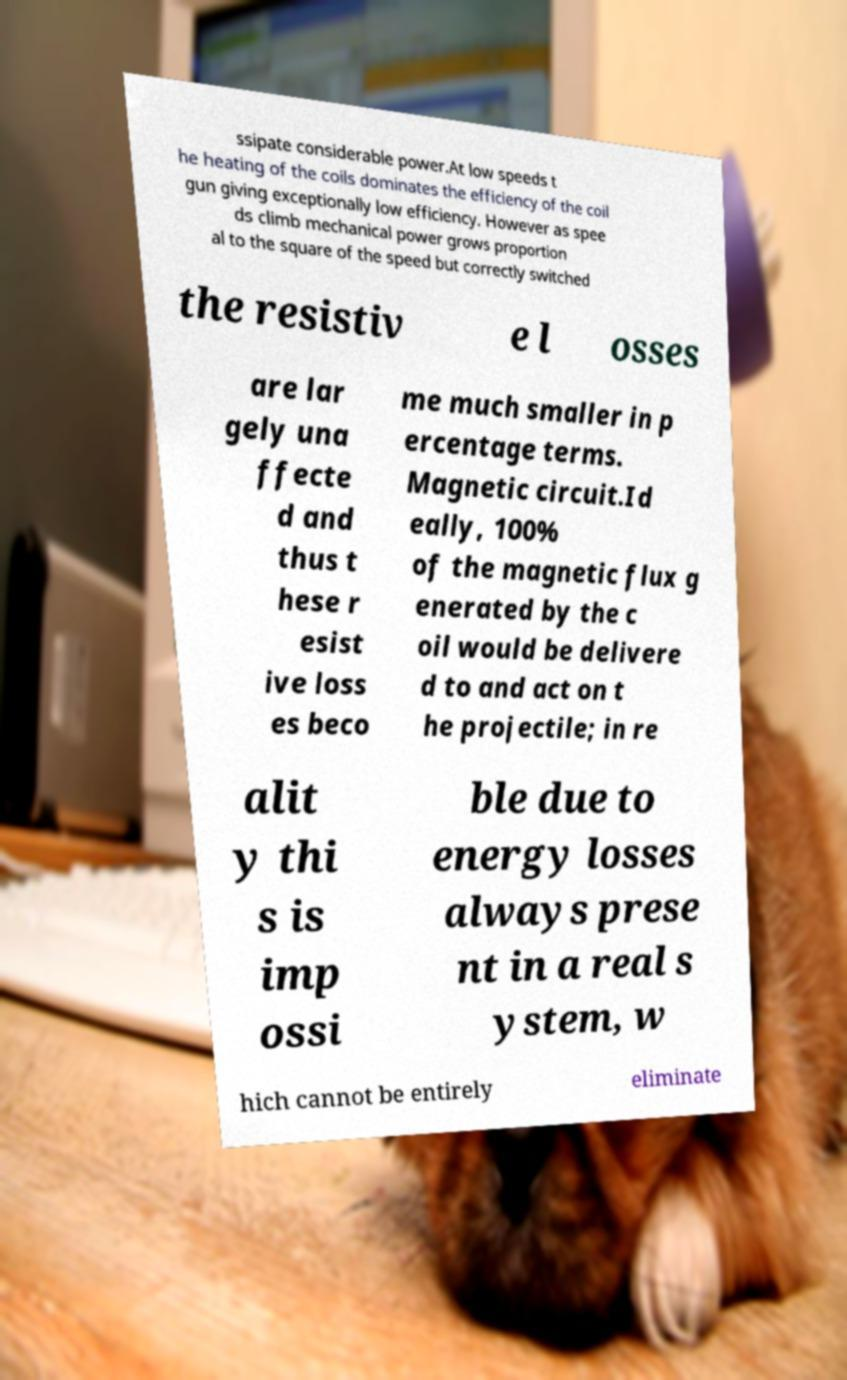Please identify and transcribe the text found in this image. ssipate considerable power.At low speeds t he heating of the coils dominates the efficiency of the coil gun giving exceptionally low efficiency. However as spee ds climb mechanical power grows proportion al to the square of the speed but correctly switched the resistiv e l osses are lar gely una ffecte d and thus t hese r esist ive loss es beco me much smaller in p ercentage terms. Magnetic circuit.Id eally, 100% of the magnetic flux g enerated by the c oil would be delivere d to and act on t he projectile; in re alit y thi s is imp ossi ble due to energy losses always prese nt in a real s ystem, w hich cannot be entirely eliminate 